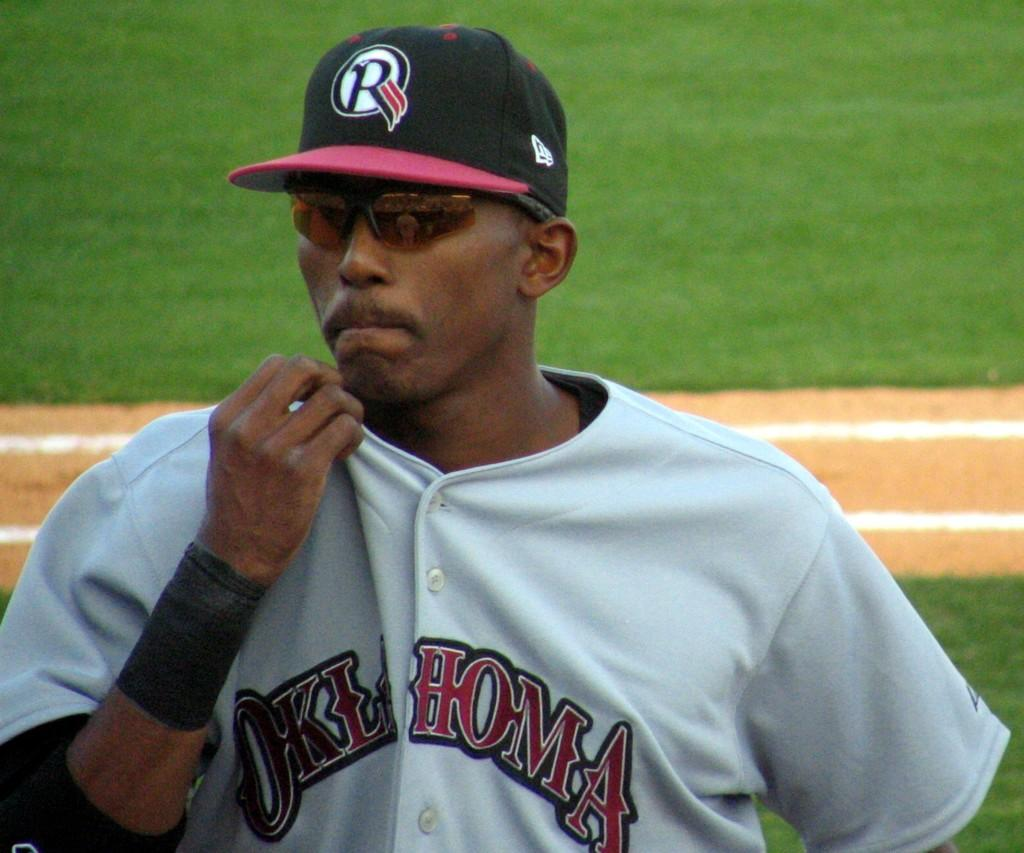Provide a one-sentence caption for the provided image. Baseball player wearing a jersey which says Oklahoma standing on the field. 